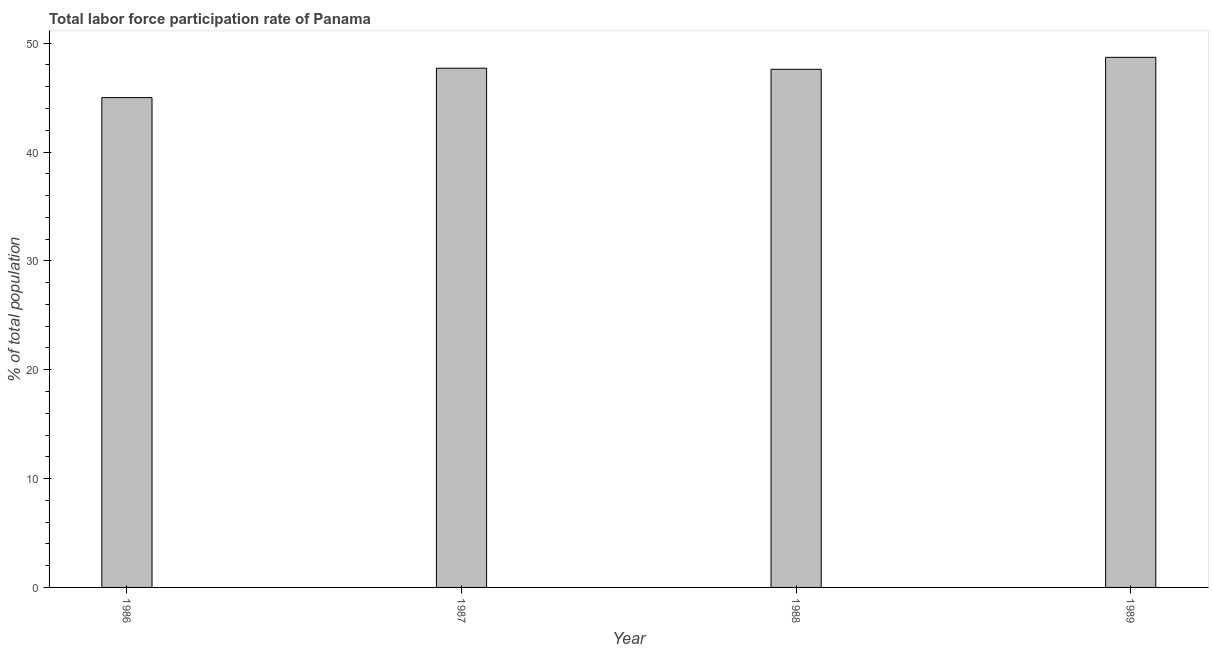What is the title of the graph?
Make the answer very short. Total labor force participation rate of Panama. What is the label or title of the Y-axis?
Give a very brief answer. % of total population. What is the total labor force participation rate in 1986?
Provide a short and direct response. 45. Across all years, what is the maximum total labor force participation rate?
Offer a terse response. 48.7. In which year was the total labor force participation rate maximum?
Provide a short and direct response. 1989. In which year was the total labor force participation rate minimum?
Provide a short and direct response. 1986. What is the sum of the total labor force participation rate?
Give a very brief answer. 189. What is the difference between the total labor force participation rate in 1986 and 1987?
Offer a very short reply. -2.7. What is the average total labor force participation rate per year?
Give a very brief answer. 47.25. What is the median total labor force participation rate?
Keep it short and to the point. 47.65. What is the ratio of the total labor force participation rate in 1987 to that in 1989?
Give a very brief answer. 0.98. Is the sum of the total labor force participation rate in 1988 and 1989 greater than the maximum total labor force participation rate across all years?
Your answer should be very brief. Yes. In how many years, is the total labor force participation rate greater than the average total labor force participation rate taken over all years?
Make the answer very short. 3. How many bars are there?
Offer a terse response. 4. How many years are there in the graph?
Offer a very short reply. 4. What is the % of total population of 1987?
Offer a terse response. 47.7. What is the % of total population in 1988?
Your answer should be very brief. 47.6. What is the % of total population in 1989?
Offer a terse response. 48.7. What is the difference between the % of total population in 1986 and 1987?
Your response must be concise. -2.7. What is the difference between the % of total population in 1986 and 1988?
Ensure brevity in your answer.  -2.6. What is the difference between the % of total population in 1986 and 1989?
Offer a terse response. -3.7. What is the ratio of the % of total population in 1986 to that in 1987?
Provide a short and direct response. 0.94. What is the ratio of the % of total population in 1986 to that in 1988?
Offer a very short reply. 0.94. What is the ratio of the % of total population in 1986 to that in 1989?
Keep it short and to the point. 0.92. What is the ratio of the % of total population in 1987 to that in 1989?
Ensure brevity in your answer.  0.98. 